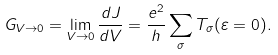Convert formula to latex. <formula><loc_0><loc_0><loc_500><loc_500>G _ { V \to 0 } = \lim _ { V \rightarrow 0 } \frac { d J } { d V } = \frac { e ^ { 2 } } { h } \sum _ { \sigma } T _ { \sigma } ( \varepsilon = 0 ) .</formula> 